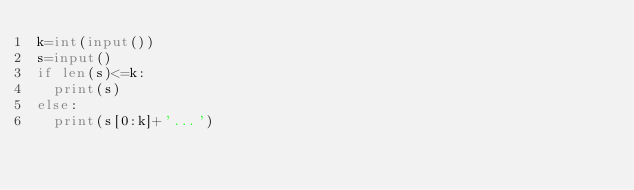Convert code to text. <code><loc_0><loc_0><loc_500><loc_500><_Python_>k=int(input())
s=input()
if len(s)<=k:
  print(s)
else:
  print(s[0:k]+'...')</code> 